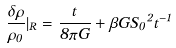Convert formula to latex. <formula><loc_0><loc_0><loc_500><loc_500>\frac { { \delta } { \rho } } { { \rho } _ { 0 } } | _ { R } = \frac { t } { 8 { \pi } G } + { \beta } G { S _ { 0 } } ^ { 2 } { t } ^ { - 1 }</formula> 